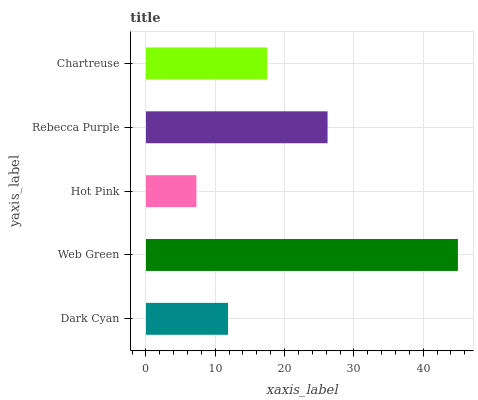Is Hot Pink the minimum?
Answer yes or no. Yes. Is Web Green the maximum?
Answer yes or no. Yes. Is Web Green the minimum?
Answer yes or no. No. Is Hot Pink the maximum?
Answer yes or no. No. Is Web Green greater than Hot Pink?
Answer yes or no. Yes. Is Hot Pink less than Web Green?
Answer yes or no. Yes. Is Hot Pink greater than Web Green?
Answer yes or no. No. Is Web Green less than Hot Pink?
Answer yes or no. No. Is Chartreuse the high median?
Answer yes or no. Yes. Is Chartreuse the low median?
Answer yes or no. Yes. Is Rebecca Purple the high median?
Answer yes or no. No. Is Hot Pink the low median?
Answer yes or no. No. 